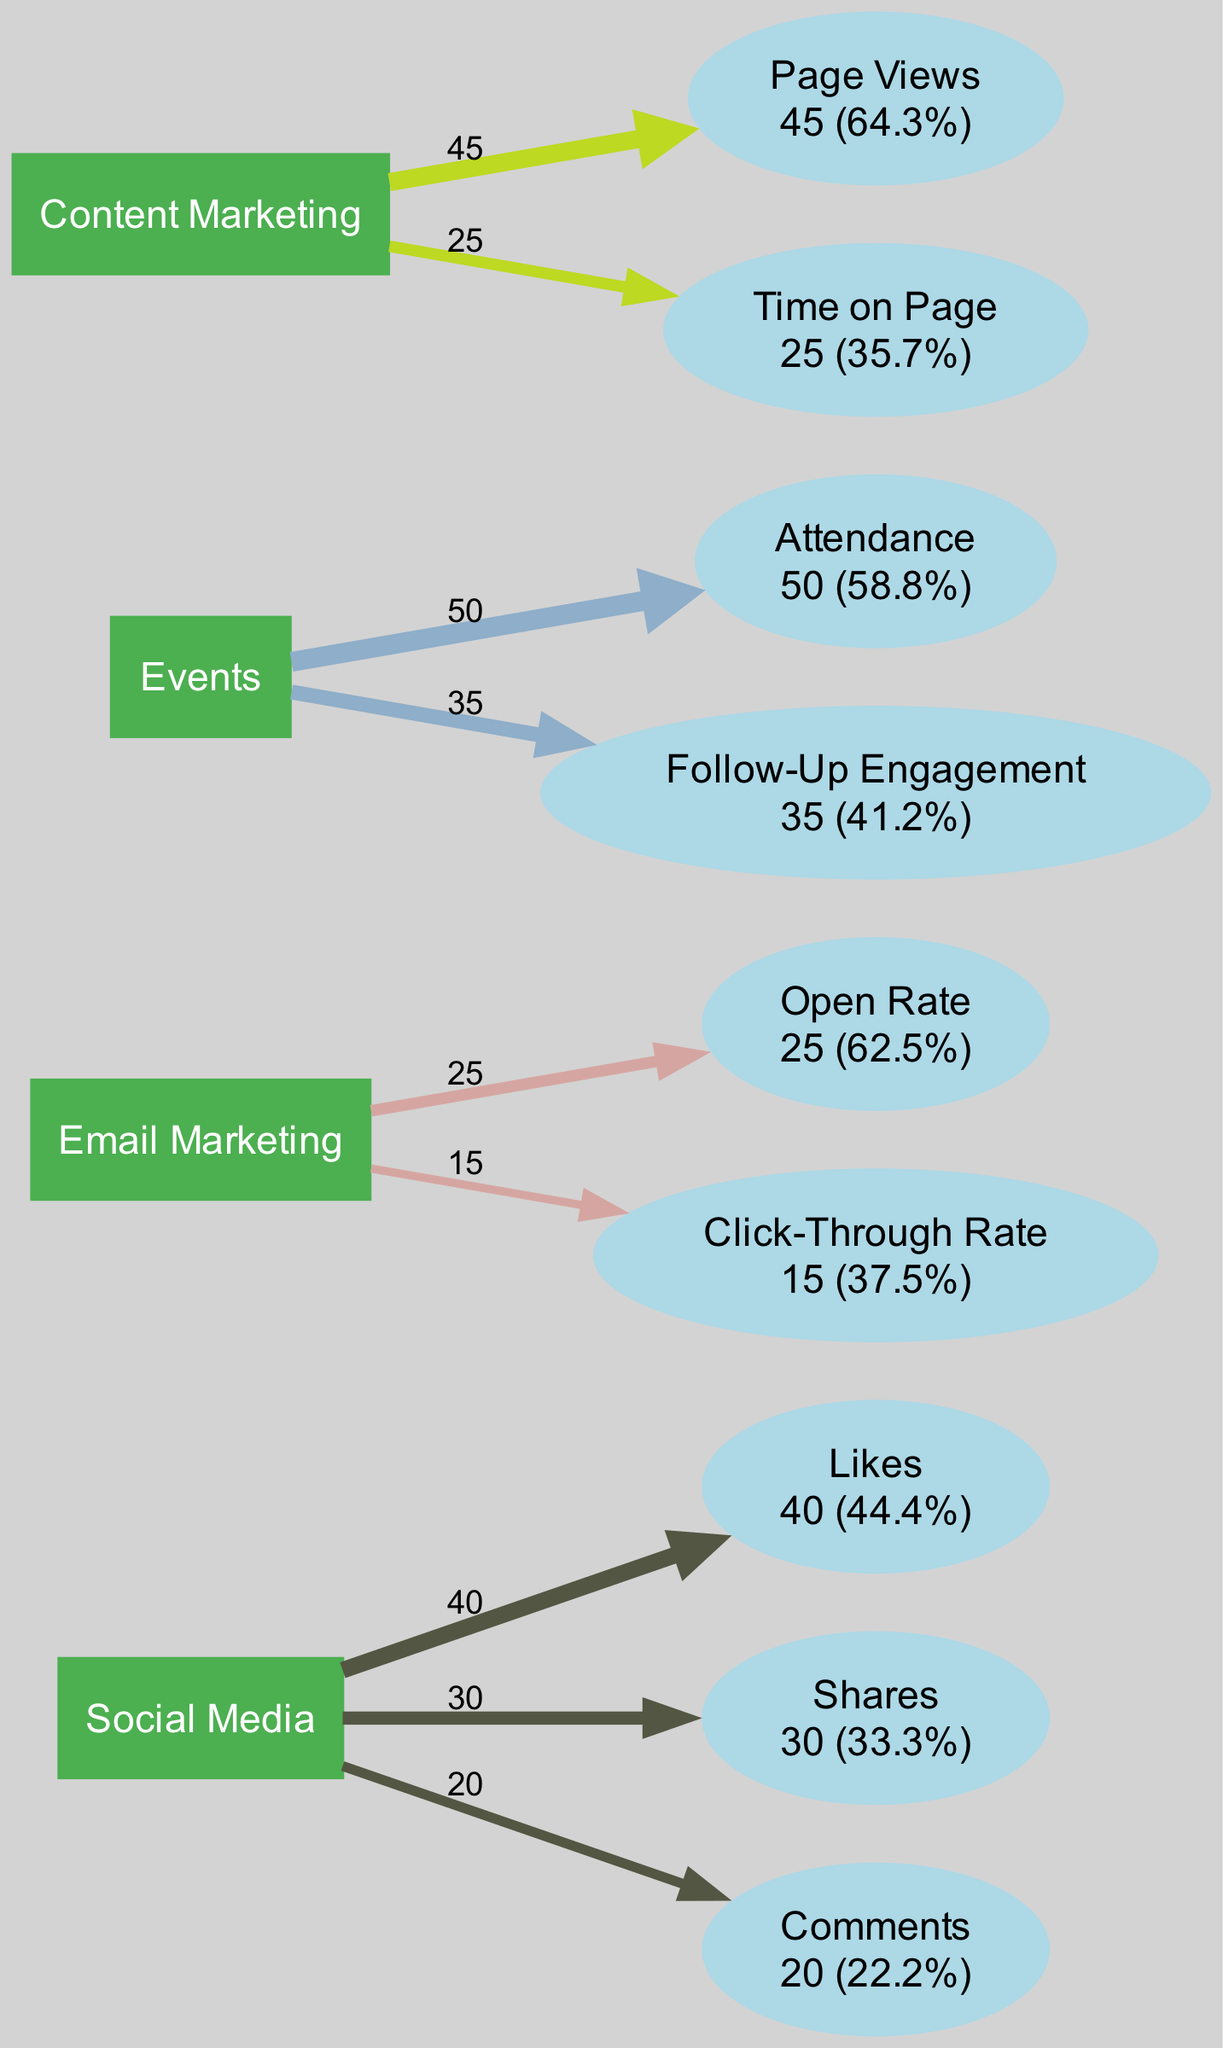What is the total number of metrics for the "Email Marketing" channel? The "Email Marketing" channel has two metrics: "Open Rate" and "Click-Through Rate". Thus, the total number is 2.
Answer: 2 Which engagement metric contributes the least percentage from "Social Media"? The "Comments" metric under "Social Media" has the lowest value of 20, which is a percentage of 20% of the total for that channel.
Answer: Comments What is the total engagement from the "Events" channel? The total engagement for the "Events" channel is calculated by adding "Attendance" (50) and "Follow-Up Engagement" (35), resulting in a total of 85.
Answer: 85 Which channel has the highest individual engagement metric value? The "Attendance" metric from the "Events" channel has the highest value of 50 among all metrics.
Answer: Attendance What is the percentage of "Shares" compared to the total metric value for "Social Media"? The total for "Social Media" is 40 (Likes) + 30 (Shares) + 20 (Comments) = 90. The "Shares" metric value is 30, so the percentage is (30/90)*100 = 33.3%.
Answer: 33.3% Which channel has a metric labeled "Time on Page"? The "Time on Page" metric is labeled under the "Content Marketing" channel.
Answer: Content Marketing What is the total number of nodes in the diagram? The total nodes include one for each channel (4) and one for each metric within those channels. There are two metrics for "Email Marketing" (2), two for "Social Media" (3), two for "Events" (2), and two for "Content Marketing" (2) for a total of 4 + 2 + 3 + 2 + 2 = 13.
Answer: 13 Which channel has the lowest total engagement when considering individual metrics? The "Email Marketing" channel has a total of 40 (25 from Open Rate and 15 from Click-Through Rate), making it the lowest total engagement channel.
Answer: Email Marketing What percentage of the total engagement does "Follow-Up Engagement" represent in the "Events" channel? Total engagement for the "Events" channel is 85, and "Follow-Up Engagement" is 35. Therefore, (35/85)*100 = 41.2%.
Answer: 41.2% 